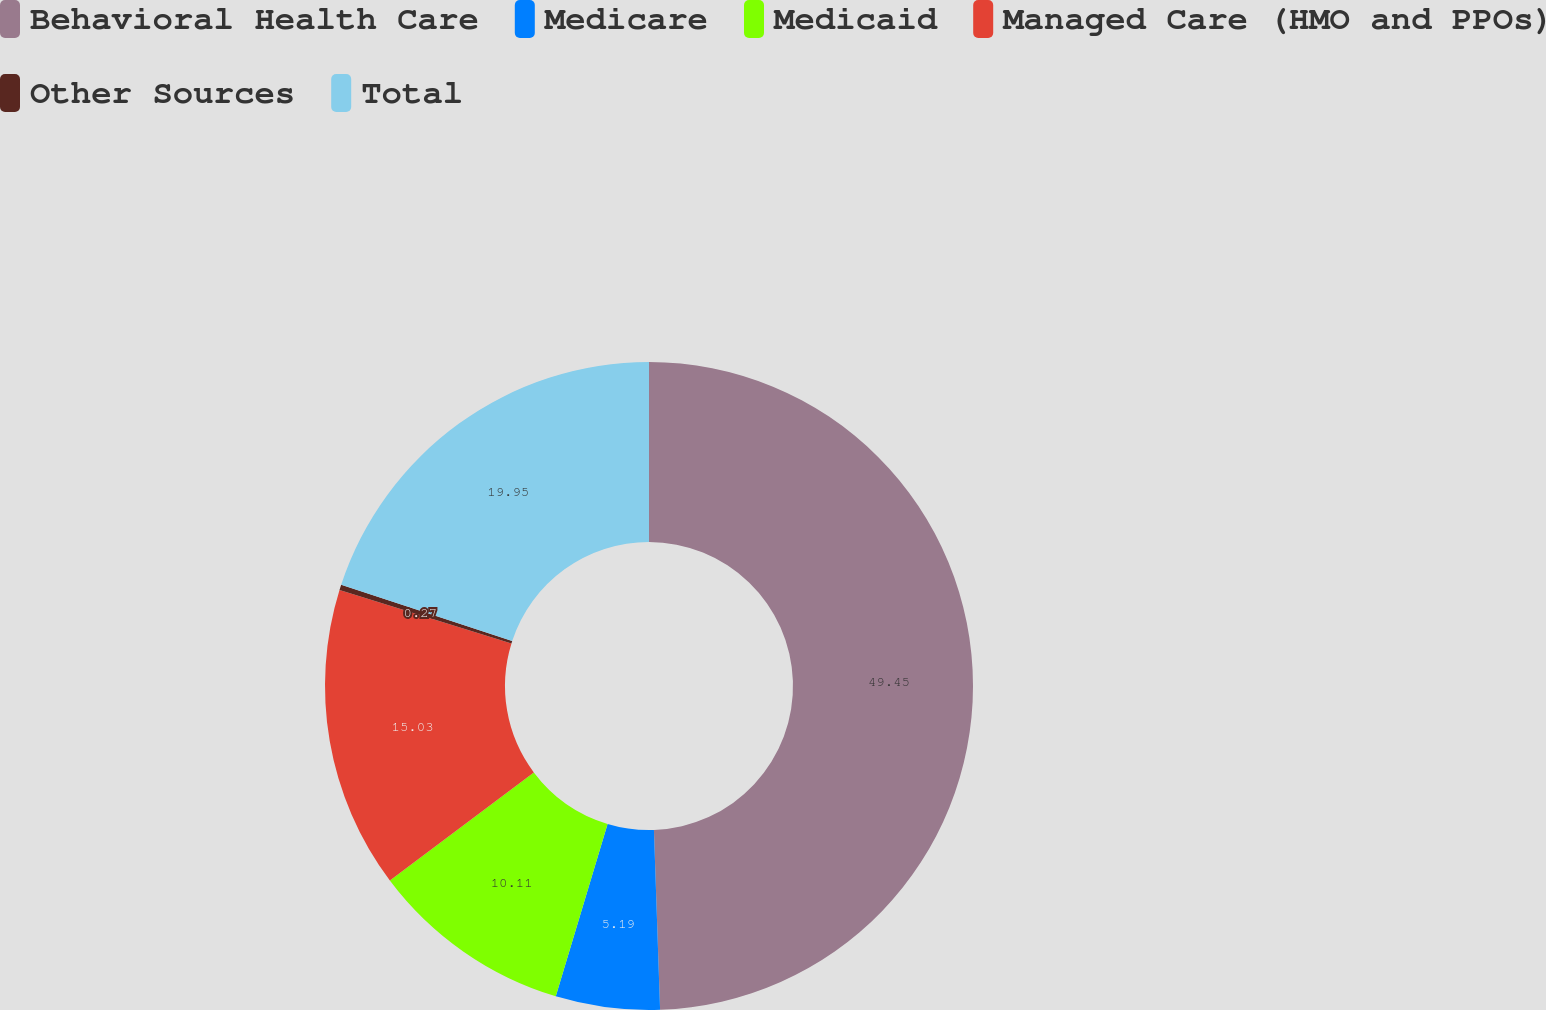<chart> <loc_0><loc_0><loc_500><loc_500><pie_chart><fcel>Behavioral Health Care<fcel>Medicare<fcel>Medicaid<fcel>Managed Care (HMO and PPOs)<fcel>Other Sources<fcel>Total<nl><fcel>49.46%<fcel>5.19%<fcel>10.11%<fcel>15.03%<fcel>0.27%<fcel>19.95%<nl></chart> 